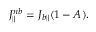<formula> <loc_0><loc_0><loc_500><loc_500>J _ { \| } ^ { n b } = J _ { b \| } ( 1 - A ) .</formula> 